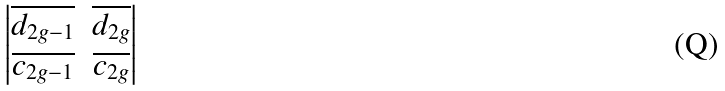Convert formula to latex. <formula><loc_0><loc_0><loc_500><loc_500>\begin{vmatrix} \overline { d _ { 2 g - 1 } } & \overline { d _ { 2 g } } \\ \overline { c _ { 2 g - 1 } } & \overline { c _ { 2 g } } \end{vmatrix}</formula> 